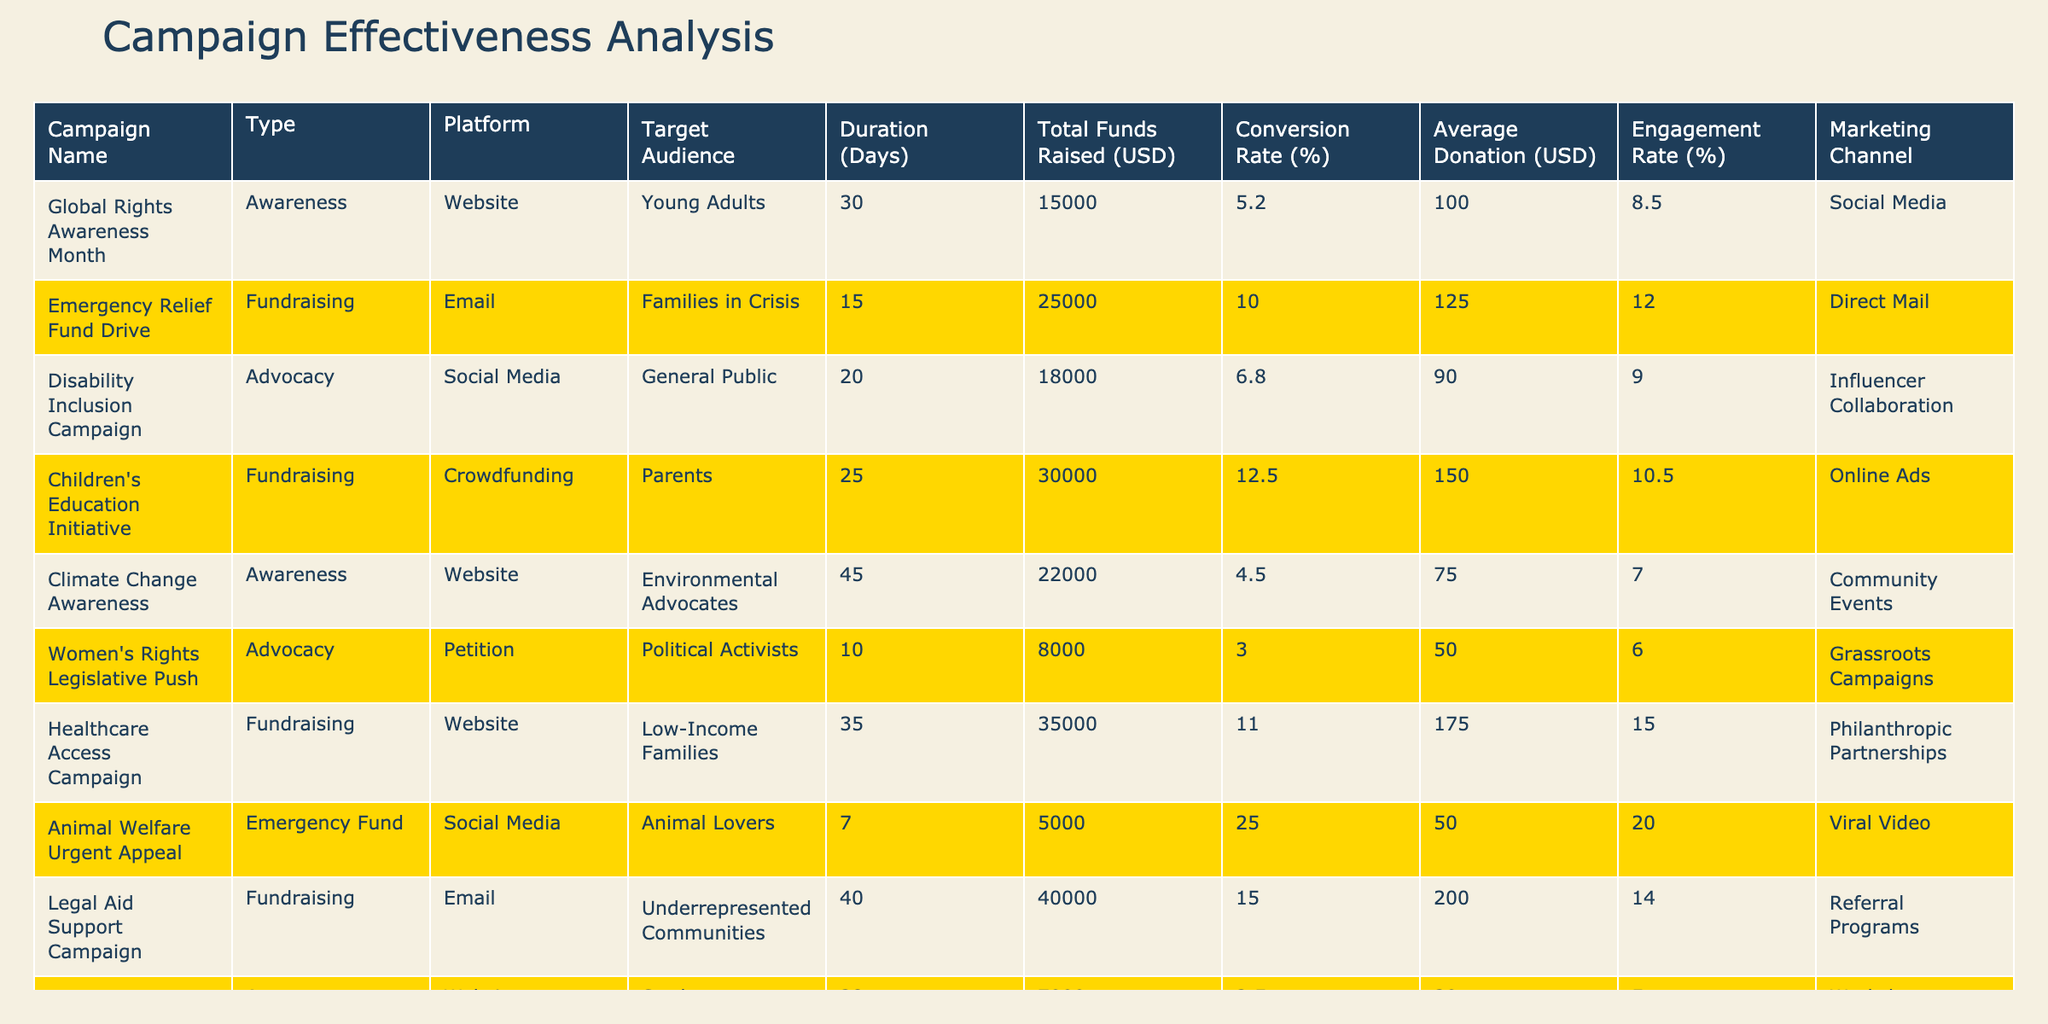What is the total funds raised by the "Children's Education Initiative"? The "Children's Education Initiative" raised a total of 30000 USD, as indicated in the table under the "Total Funds Raised (USD)" column for this specific campaign.
Answer: 30000 What is the average donation amount for the "Healthcare Access Campaign"? The average donation amount for the "Healthcare Access Campaign" is 175 USD, which can be found in the "Average Donation (USD)" column for this campaign.
Answer: 175 Which campaign has the highest conversion rate? The campaign with the highest conversion rate is the "Animal Welfare Urgent Appeal," which has a conversion rate of 25.0%. This is noted under the "Conversion Rate (%)" column of the respective campaign.
Answer: 25.0% What is the total funds raised from all awareness campaigns? To find the total funds raised from awareness campaigns, we add the funds raised from "Global Rights Awareness Month" (15000 USD), "Climate Change Awareness" (22000 USD), and "Human Trafficking Awareness Drive" (7000 USD). The sum is 15000 + 22000 + 7000 = 44000 USD.
Answer: 44000 Is the "Disability Inclusion Campaign" more effective in terms of conversion rate than the "Women's Rights Legislative Push"? Yes, the "Disability Inclusion Campaign" has a conversion rate of 6.8%, whereas the "Women's Rights Legislative Push" has a conversion rate of 3.0%. Therefore, the former is more effective in this regard.
Answer: Yes What is the average engagement rate across all fundraisers? The engagement rates for all fundraising campaigns are: "Emergency Relief Fund Drive" (12.0%), "Children's Education Initiative" (10.5%), "Healthcare Access Campaign" (15.0%), and "Legal Aid Support Campaign" (14.0%). First, sum these rates: 12.0 + 10.5 + 15.0 + 14.0 = 51.5%. There are four campaigns, so the average is 51.5 / 4 = 12.875%.
Answer: 12.875 Which marketing channel generated the least funds and what was that amount? The marketing channel that generated the least funds is the "Animal Welfare Urgent Appeal" with only 5000 USD raised. This is the lowest value found in the "Total Funds Raised (USD)" column.
Answer: 5000 How many days did the "Climate Change Awareness" campaign run compared to the "Women's Rights Legislative Push"? The "Climate Change Awareness" campaign ran for 45 days while the "Women's Rights Legislative Push" ran for 10 days. The difference is 45 - 10 = 35 days.
Answer: 35 days Which campaign had the highest average donation per contributor? The campaign with the highest average donation per contributor is the "Legal Aid Support Campaign," which had an average donation of 200 USD, referenced in the "Average Donation (USD)" column.
Answer: 200 